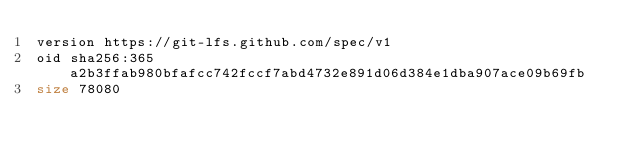Convert code to text. <code><loc_0><loc_0><loc_500><loc_500><_COBOL_>version https://git-lfs.github.com/spec/v1
oid sha256:365a2b3ffab980bfafcc742fccf7abd4732e891d06d384e1dba907ace09b69fb
size 78080
</code> 